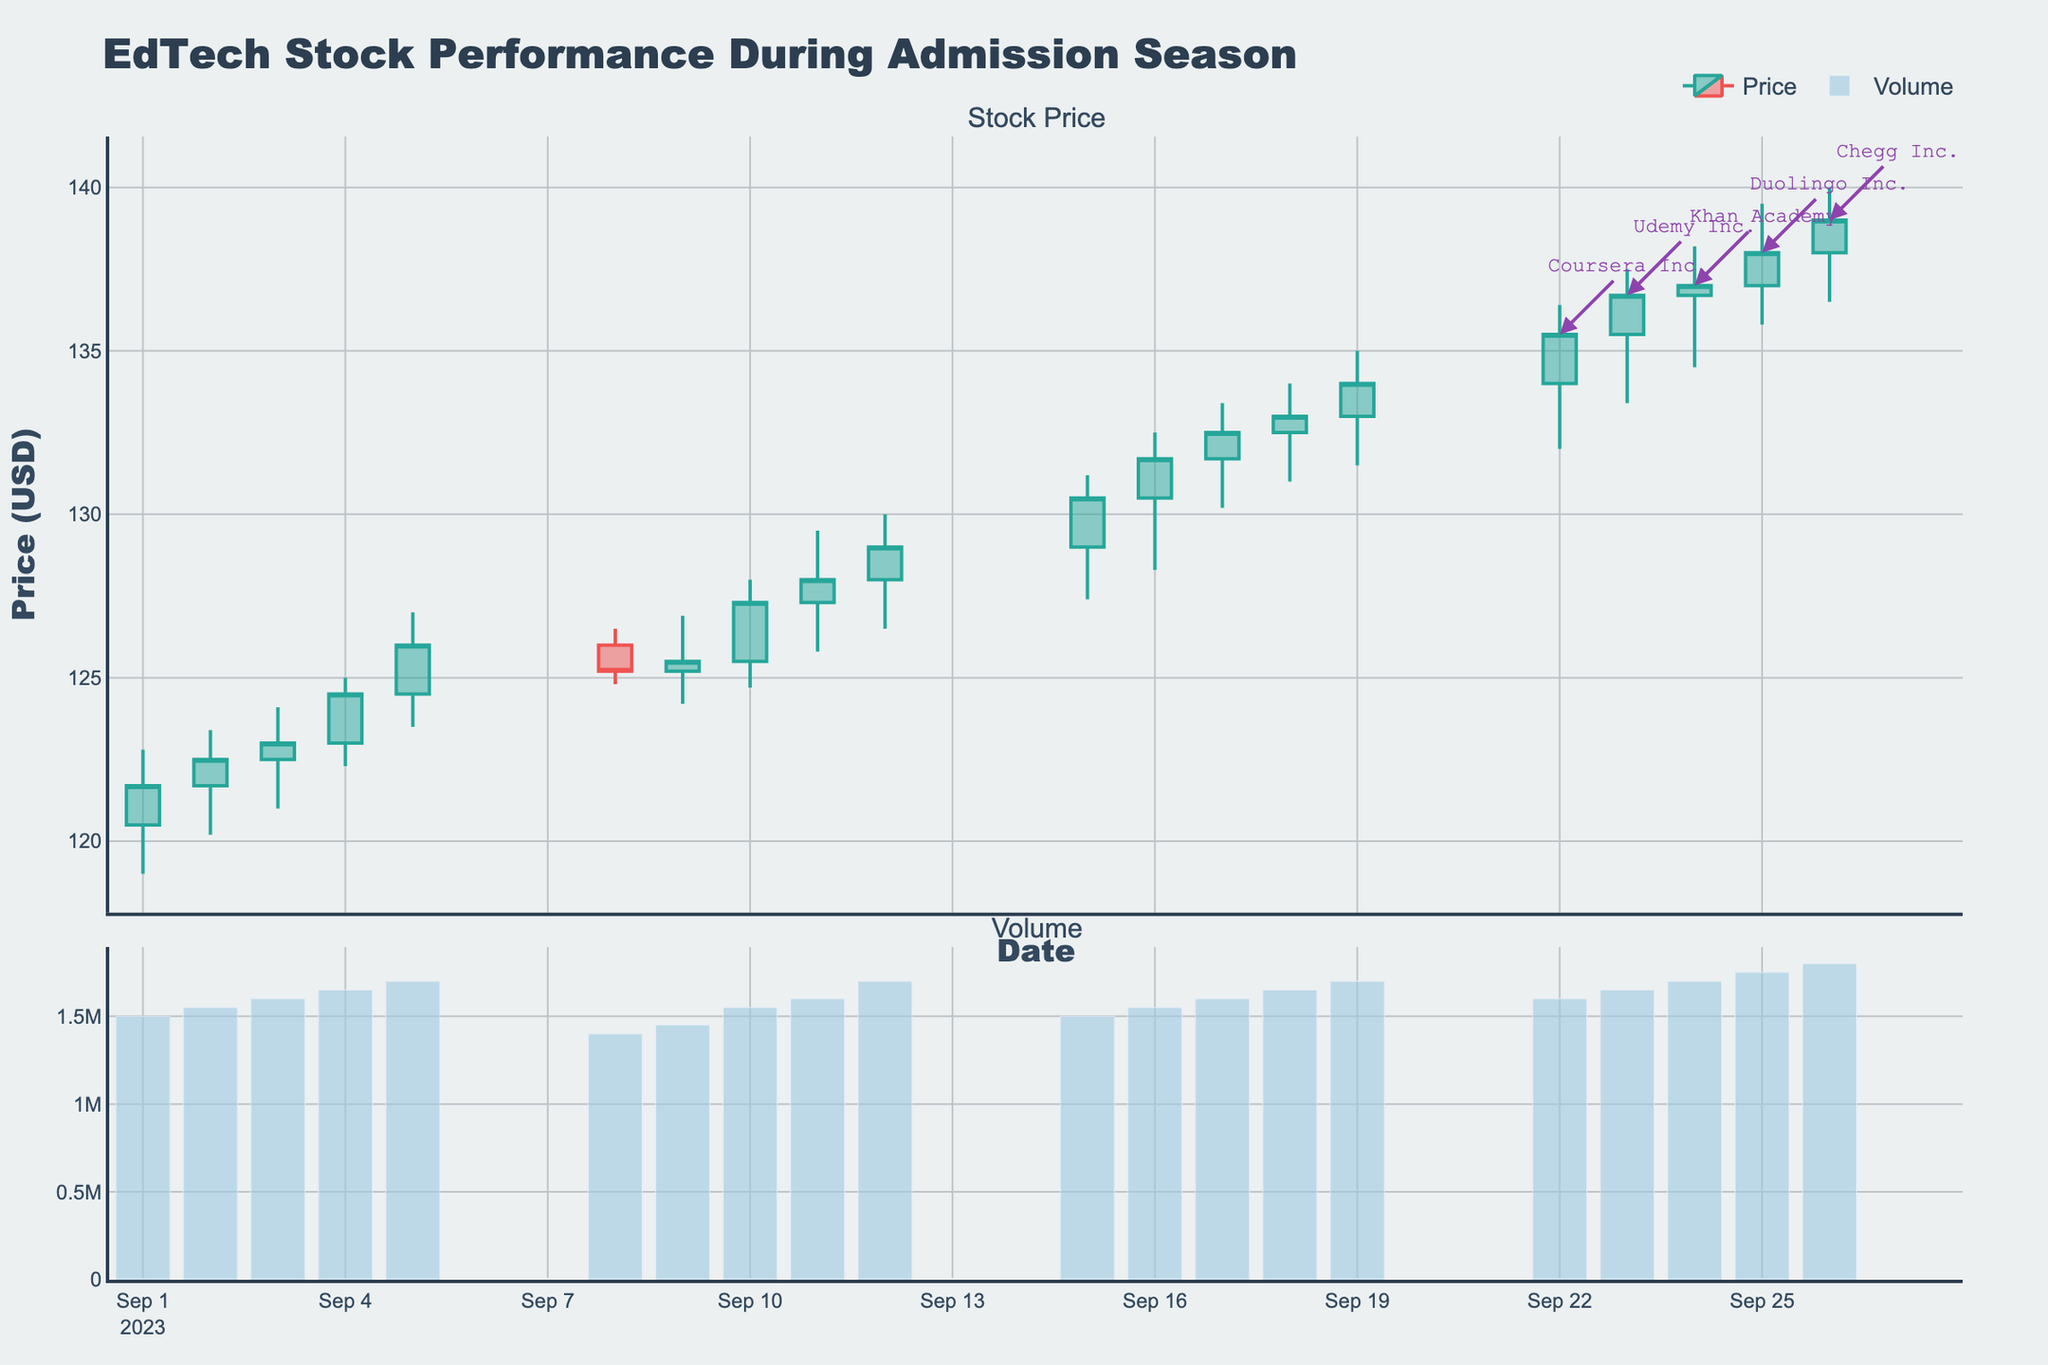What is the title of the chart? The title is prominently displayed at the top of the chart, written in a larger font.
Answer: EdTech Stock Performance During Admission Season Which stock closed at the highest price and on what date did it occur? Look for the highest value on the "Close" axis and check which date aligns with that value.
Answer: Chegg Inc. on 2023-09-26 What are the x-axis and y-axis titles of the candlestick chart? The x-axis at the bottom of the chart shows "Date" and the y-axis on the left shows "Price (USD)".
Answer: Date, Price (USD) How many different companies are represented in the chart? By observing the legend and annotations, count the number of unique company names listed.
Answer: 5 Which company had the highest volume traded and what was the volume? Look at the bars in the volume subplot and find the tallest one, then check the corresponding company and volume value.
Answer: Chegg Inc., 1,800,000 What was the closing price of Coursera Inc. on 2023-09-15? Locate the candlestick for 2023-09-15, note the closing price indicated at the top or bottom of the candlestick.
Answer: 130.5 Between which dates did Coursera Inc.'s stock open at the highest price? Look for the candlestick with the highest "Open" value for Coursera Inc. and note the dates surrounding it.
Answer: 2023-09-15 to 2023-09-22 Which company showed the greatest daily price increase and on which date did it occur? Calculate the difference between the high and low values for each day, then find the maximum difference and check the corresponding company and date.
Answer: Khan Academy on 2023-09-17 Considering the entire period, which stock showed the smallest volatility, or least fluctuation in daily prices? Inspect the range (high minus low) for each company's stock across all dates, find the one with the lowest average range.
Answer: Coursera Inc On 2023-09-19, which company had a closing price higher than 134? Check closing prices on 2023-09-19 for all companies and note which ones are higher than 134.
Answer: Chegg Inc 